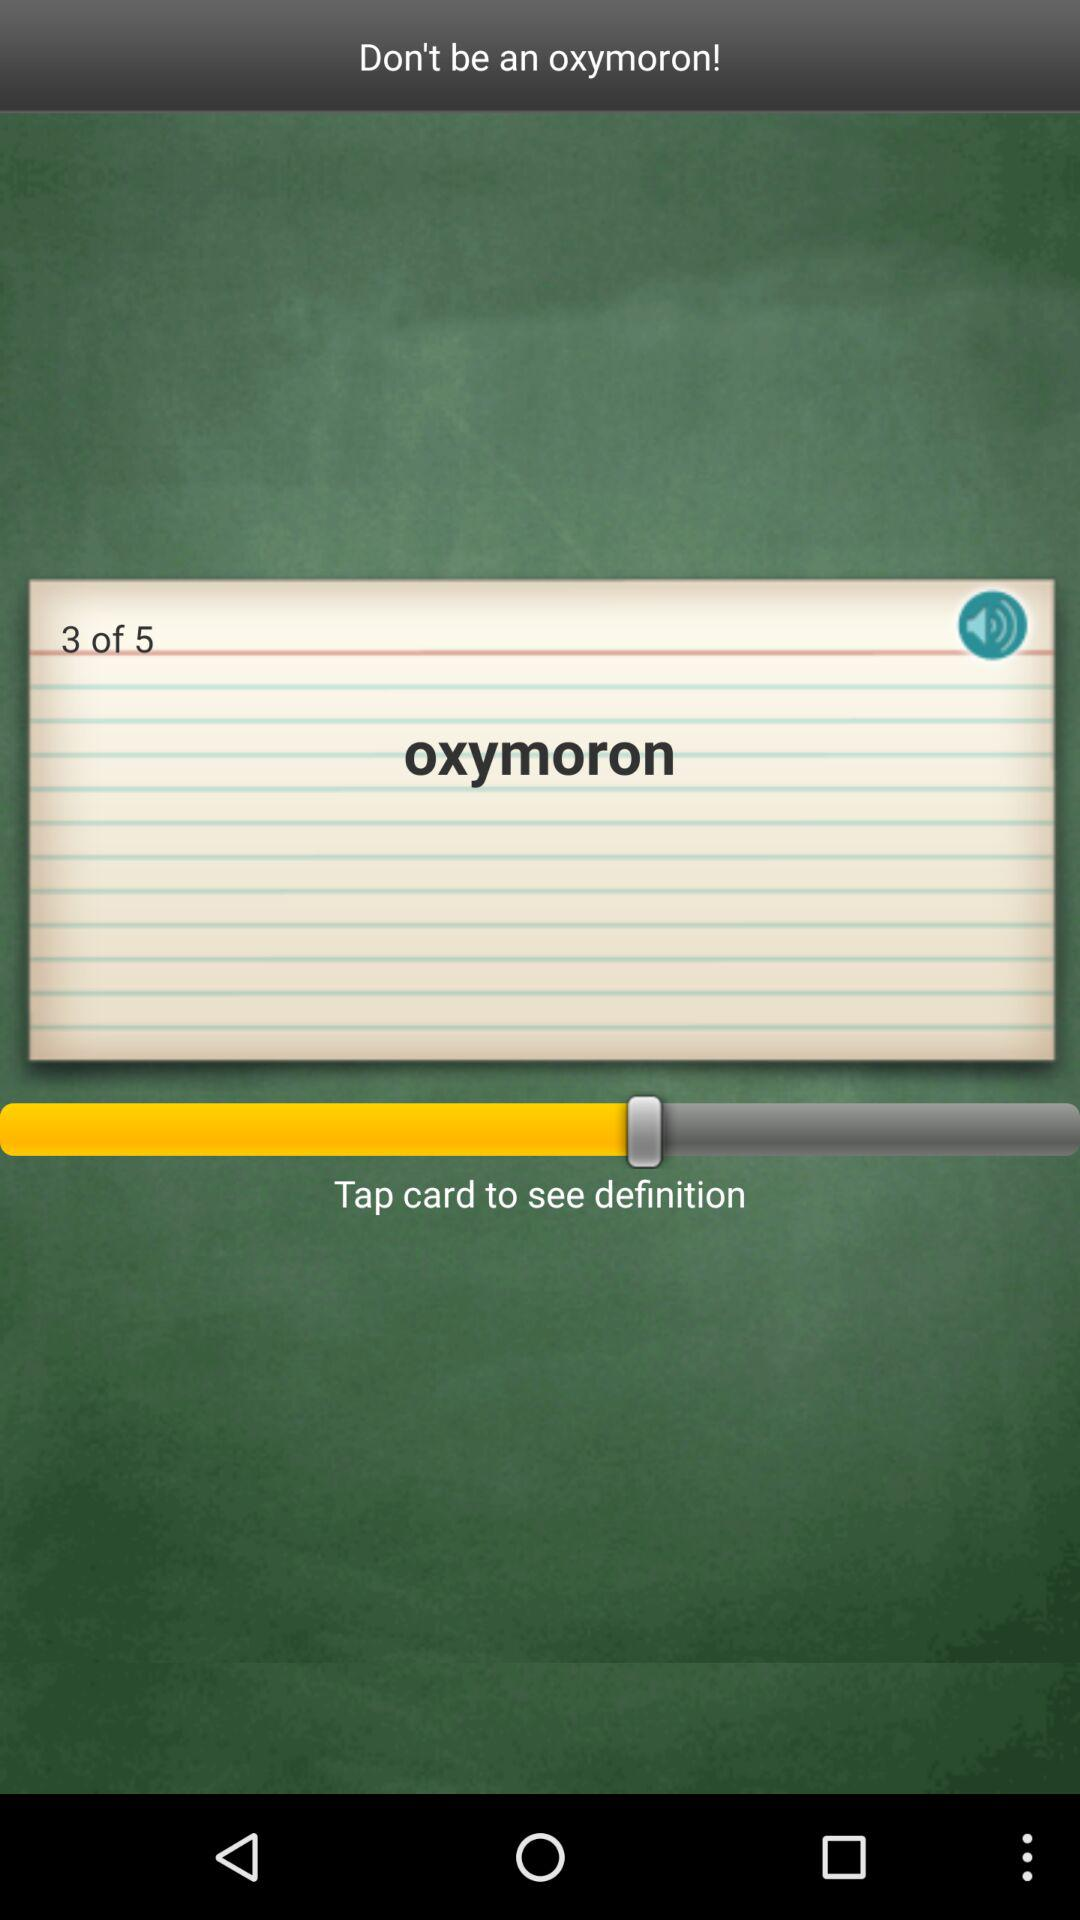How many pages in total are there? There are 5 pages in total. 